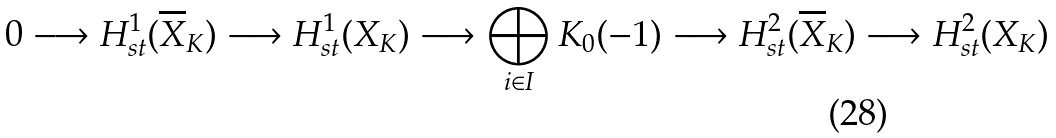Convert formula to latex. <formula><loc_0><loc_0><loc_500><loc_500>0 \longrightarrow H ^ { 1 } _ { s t } ( \overline { X } _ { K } ) \longrightarrow H ^ { 1 } _ { s t } ( X _ { K } ) \longrightarrow \bigoplus _ { i \in I } K _ { 0 } ( - 1 ) \longrightarrow H ^ { 2 } _ { s t } ( \overline { X } _ { K } ) \longrightarrow H ^ { 2 } _ { s t } ( X _ { K } )</formula> 